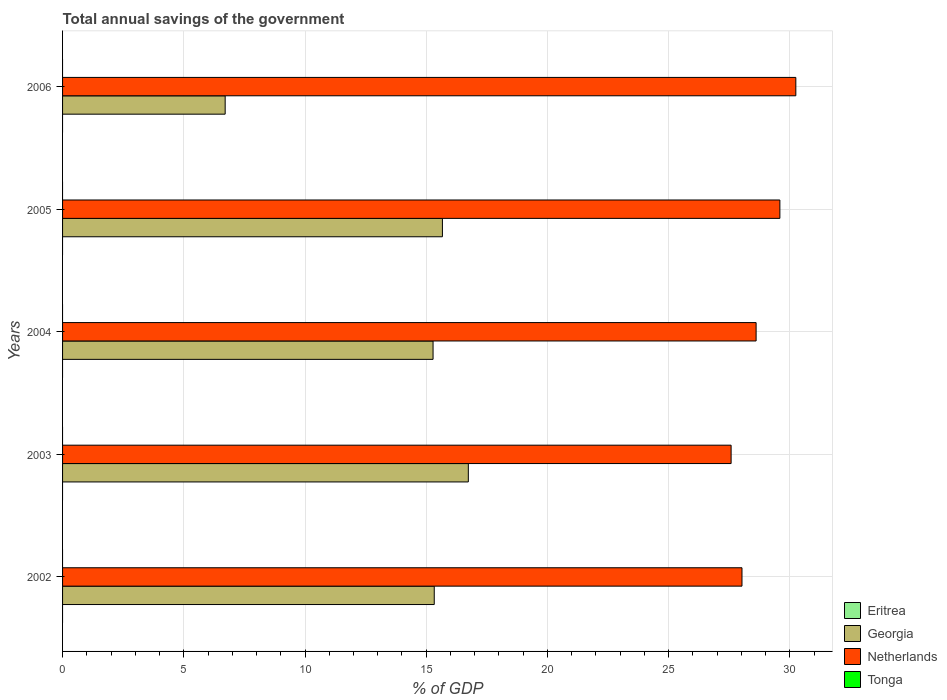How many groups of bars are there?
Your answer should be compact. 5. Are the number of bars per tick equal to the number of legend labels?
Your response must be concise. No. What is the label of the 2nd group of bars from the top?
Offer a terse response. 2005. In how many cases, is the number of bars for a given year not equal to the number of legend labels?
Offer a very short reply. 5. What is the total annual savings of the government in Georgia in 2002?
Your answer should be compact. 15.33. Across all years, what is the maximum total annual savings of the government in Georgia?
Your answer should be very brief. 16.74. Across all years, what is the minimum total annual savings of the government in Eritrea?
Provide a short and direct response. 0. What is the total total annual savings of the government in Netherlands in the graph?
Your answer should be very brief. 144.04. What is the difference between the total annual savings of the government in Netherlands in 2002 and that in 2003?
Offer a very short reply. 0.45. In the year 2004, what is the difference between the total annual savings of the government in Georgia and total annual savings of the government in Netherlands?
Provide a succinct answer. -13.32. What is the ratio of the total annual savings of the government in Netherlands in 2005 to that in 2006?
Your answer should be compact. 0.98. Is the difference between the total annual savings of the government in Georgia in 2003 and 2004 greater than the difference between the total annual savings of the government in Netherlands in 2003 and 2004?
Offer a very short reply. Yes. What is the difference between the highest and the second highest total annual savings of the government in Netherlands?
Provide a short and direct response. 0.66. What is the difference between the highest and the lowest total annual savings of the government in Georgia?
Provide a short and direct response. 10.03. In how many years, is the total annual savings of the government in Tonga greater than the average total annual savings of the government in Tonga taken over all years?
Provide a succinct answer. 0. Is the sum of the total annual savings of the government in Netherlands in 2003 and 2004 greater than the maximum total annual savings of the government in Tonga across all years?
Offer a terse response. Yes. Is it the case that in every year, the sum of the total annual savings of the government in Netherlands and total annual savings of the government in Tonga is greater than the total annual savings of the government in Eritrea?
Make the answer very short. Yes. How many years are there in the graph?
Provide a short and direct response. 5. Are the values on the major ticks of X-axis written in scientific E-notation?
Offer a very short reply. No. Does the graph contain grids?
Provide a short and direct response. Yes. Where does the legend appear in the graph?
Your response must be concise. Bottom right. How many legend labels are there?
Offer a very short reply. 4. What is the title of the graph?
Offer a very short reply. Total annual savings of the government. Does "Kazakhstan" appear as one of the legend labels in the graph?
Make the answer very short. No. What is the label or title of the X-axis?
Make the answer very short. % of GDP. What is the label or title of the Y-axis?
Keep it short and to the point. Years. What is the % of GDP of Georgia in 2002?
Provide a succinct answer. 15.33. What is the % of GDP of Netherlands in 2002?
Your answer should be compact. 28.02. What is the % of GDP of Tonga in 2002?
Your answer should be very brief. 0. What is the % of GDP in Georgia in 2003?
Offer a terse response. 16.74. What is the % of GDP of Netherlands in 2003?
Offer a terse response. 27.58. What is the % of GDP of Georgia in 2004?
Keep it short and to the point. 15.28. What is the % of GDP in Netherlands in 2004?
Ensure brevity in your answer.  28.61. What is the % of GDP in Georgia in 2005?
Your response must be concise. 15.67. What is the % of GDP of Netherlands in 2005?
Keep it short and to the point. 29.59. What is the % of GDP in Eritrea in 2006?
Ensure brevity in your answer.  0. What is the % of GDP of Georgia in 2006?
Offer a very short reply. 6.71. What is the % of GDP in Netherlands in 2006?
Offer a very short reply. 30.24. What is the % of GDP in Tonga in 2006?
Offer a terse response. 0. Across all years, what is the maximum % of GDP of Georgia?
Make the answer very short. 16.74. Across all years, what is the maximum % of GDP of Netherlands?
Give a very brief answer. 30.24. Across all years, what is the minimum % of GDP of Georgia?
Provide a succinct answer. 6.71. Across all years, what is the minimum % of GDP of Netherlands?
Provide a short and direct response. 27.58. What is the total % of GDP of Eritrea in the graph?
Give a very brief answer. 0. What is the total % of GDP of Georgia in the graph?
Offer a terse response. 69.72. What is the total % of GDP of Netherlands in the graph?
Your response must be concise. 144.04. What is the difference between the % of GDP in Georgia in 2002 and that in 2003?
Your answer should be compact. -1.41. What is the difference between the % of GDP in Netherlands in 2002 and that in 2003?
Offer a terse response. 0.45. What is the difference between the % of GDP of Georgia in 2002 and that in 2004?
Offer a very short reply. 0.05. What is the difference between the % of GDP of Netherlands in 2002 and that in 2004?
Provide a short and direct response. -0.58. What is the difference between the % of GDP in Georgia in 2002 and that in 2005?
Your response must be concise. -0.34. What is the difference between the % of GDP in Netherlands in 2002 and that in 2005?
Offer a very short reply. -1.56. What is the difference between the % of GDP of Georgia in 2002 and that in 2006?
Ensure brevity in your answer.  8.62. What is the difference between the % of GDP of Netherlands in 2002 and that in 2006?
Your answer should be compact. -2.22. What is the difference between the % of GDP in Georgia in 2003 and that in 2004?
Give a very brief answer. 1.45. What is the difference between the % of GDP of Netherlands in 2003 and that in 2004?
Give a very brief answer. -1.03. What is the difference between the % of GDP in Georgia in 2003 and that in 2005?
Make the answer very short. 1.07. What is the difference between the % of GDP in Netherlands in 2003 and that in 2005?
Provide a succinct answer. -2.01. What is the difference between the % of GDP of Georgia in 2003 and that in 2006?
Make the answer very short. 10.03. What is the difference between the % of GDP of Netherlands in 2003 and that in 2006?
Offer a very short reply. -2.67. What is the difference between the % of GDP of Georgia in 2004 and that in 2005?
Make the answer very short. -0.39. What is the difference between the % of GDP in Netherlands in 2004 and that in 2005?
Make the answer very short. -0.98. What is the difference between the % of GDP of Georgia in 2004 and that in 2006?
Make the answer very short. 8.57. What is the difference between the % of GDP of Netherlands in 2004 and that in 2006?
Ensure brevity in your answer.  -1.64. What is the difference between the % of GDP in Georgia in 2005 and that in 2006?
Make the answer very short. 8.96. What is the difference between the % of GDP in Netherlands in 2005 and that in 2006?
Your answer should be compact. -0.66. What is the difference between the % of GDP of Georgia in 2002 and the % of GDP of Netherlands in 2003?
Your answer should be compact. -12.24. What is the difference between the % of GDP in Georgia in 2002 and the % of GDP in Netherlands in 2004?
Provide a short and direct response. -13.28. What is the difference between the % of GDP in Georgia in 2002 and the % of GDP in Netherlands in 2005?
Provide a short and direct response. -14.26. What is the difference between the % of GDP of Georgia in 2002 and the % of GDP of Netherlands in 2006?
Provide a short and direct response. -14.91. What is the difference between the % of GDP of Georgia in 2003 and the % of GDP of Netherlands in 2004?
Make the answer very short. -11.87. What is the difference between the % of GDP of Georgia in 2003 and the % of GDP of Netherlands in 2005?
Give a very brief answer. -12.85. What is the difference between the % of GDP in Georgia in 2003 and the % of GDP in Netherlands in 2006?
Your answer should be compact. -13.51. What is the difference between the % of GDP in Georgia in 2004 and the % of GDP in Netherlands in 2005?
Provide a succinct answer. -14.3. What is the difference between the % of GDP of Georgia in 2004 and the % of GDP of Netherlands in 2006?
Ensure brevity in your answer.  -14.96. What is the difference between the % of GDP of Georgia in 2005 and the % of GDP of Netherlands in 2006?
Offer a terse response. -14.58. What is the average % of GDP of Eritrea per year?
Provide a succinct answer. 0. What is the average % of GDP in Georgia per year?
Your answer should be very brief. 13.94. What is the average % of GDP in Netherlands per year?
Keep it short and to the point. 28.81. In the year 2002, what is the difference between the % of GDP of Georgia and % of GDP of Netherlands?
Offer a terse response. -12.69. In the year 2003, what is the difference between the % of GDP in Georgia and % of GDP in Netherlands?
Your answer should be very brief. -10.84. In the year 2004, what is the difference between the % of GDP in Georgia and % of GDP in Netherlands?
Make the answer very short. -13.32. In the year 2005, what is the difference between the % of GDP of Georgia and % of GDP of Netherlands?
Your answer should be compact. -13.92. In the year 2006, what is the difference between the % of GDP in Georgia and % of GDP in Netherlands?
Ensure brevity in your answer.  -23.54. What is the ratio of the % of GDP in Georgia in 2002 to that in 2003?
Offer a terse response. 0.92. What is the ratio of the % of GDP in Netherlands in 2002 to that in 2003?
Your response must be concise. 1.02. What is the ratio of the % of GDP in Georgia in 2002 to that in 2004?
Your answer should be compact. 1. What is the ratio of the % of GDP in Netherlands in 2002 to that in 2004?
Ensure brevity in your answer.  0.98. What is the ratio of the % of GDP of Georgia in 2002 to that in 2005?
Offer a terse response. 0.98. What is the ratio of the % of GDP in Netherlands in 2002 to that in 2005?
Provide a succinct answer. 0.95. What is the ratio of the % of GDP of Georgia in 2002 to that in 2006?
Offer a terse response. 2.29. What is the ratio of the % of GDP of Netherlands in 2002 to that in 2006?
Give a very brief answer. 0.93. What is the ratio of the % of GDP in Georgia in 2003 to that in 2004?
Keep it short and to the point. 1.1. What is the ratio of the % of GDP in Netherlands in 2003 to that in 2004?
Your response must be concise. 0.96. What is the ratio of the % of GDP of Georgia in 2003 to that in 2005?
Provide a succinct answer. 1.07. What is the ratio of the % of GDP of Netherlands in 2003 to that in 2005?
Offer a very short reply. 0.93. What is the ratio of the % of GDP of Georgia in 2003 to that in 2006?
Your response must be concise. 2.5. What is the ratio of the % of GDP in Netherlands in 2003 to that in 2006?
Ensure brevity in your answer.  0.91. What is the ratio of the % of GDP in Georgia in 2004 to that in 2005?
Provide a short and direct response. 0.98. What is the ratio of the % of GDP in Netherlands in 2004 to that in 2005?
Provide a short and direct response. 0.97. What is the ratio of the % of GDP in Georgia in 2004 to that in 2006?
Make the answer very short. 2.28. What is the ratio of the % of GDP in Netherlands in 2004 to that in 2006?
Keep it short and to the point. 0.95. What is the ratio of the % of GDP of Georgia in 2005 to that in 2006?
Offer a terse response. 2.34. What is the ratio of the % of GDP in Netherlands in 2005 to that in 2006?
Keep it short and to the point. 0.98. What is the difference between the highest and the second highest % of GDP of Georgia?
Your response must be concise. 1.07. What is the difference between the highest and the second highest % of GDP of Netherlands?
Provide a short and direct response. 0.66. What is the difference between the highest and the lowest % of GDP in Georgia?
Give a very brief answer. 10.03. What is the difference between the highest and the lowest % of GDP of Netherlands?
Ensure brevity in your answer.  2.67. 